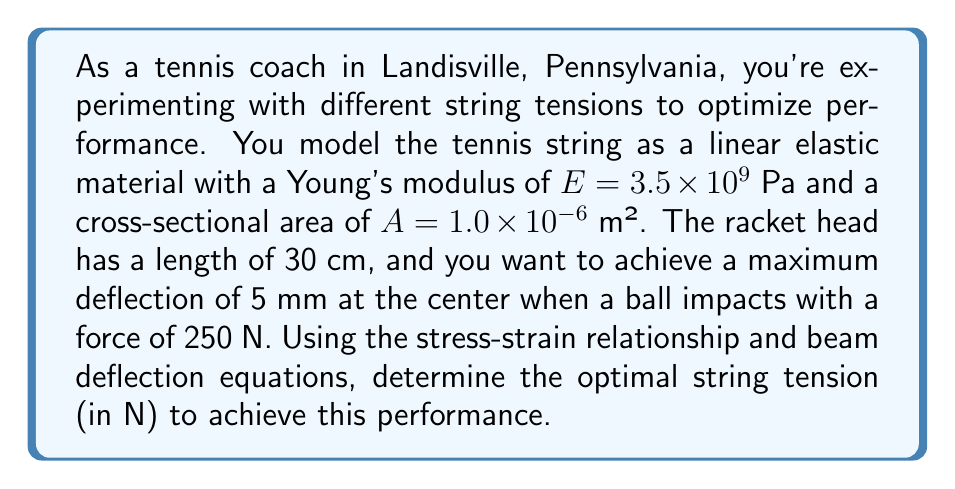Show me your answer to this math problem. To solve this problem, we'll use the following steps:

1) First, we need to use the beam deflection equation for a simply supported beam with a point load at the center:

   $$\delta_{max} = \frac{FL^3}{48EI}$$

   where $\delta_{max}$ is the maximum deflection, $F$ is the force, $L$ is the length, $E$ is Young's modulus, and $I$ is the moment of inertia.

2) We can rearrange this equation to solve for $I$:

   $$I = \frac{FL^3}{48E\delta_{max}}$$

3) Substituting the given values:

   $$I = \frac{250 \text{ N} \times (0.3 \text{ m})^3}{48 \times 3.5 \times 10^9 \text{ Pa} \times 0.005 \text{ m}} = 1.929 \times 10^{-9} \text{ m}^4$$

4) For a tensioned string, the moment of inertia is related to the tension $T$ by:

   $$I = \frac{TA^2}{4\pi^2}$$

5) We can rearrange this to solve for $T$:

   $$T = \frac{4\pi^2I}{A^2}$$

6) Substituting our calculated $I$ and the given $A$:

   $$T = \frac{4\pi^2 \times 1.929 \times 10^{-9} \text{ m}^4}{(1.0 \times 10^{-6} \text{ m}^2)^2} = 759.8 \text{ N}$$

Therefore, the optimal string tension is approximately 760 N.
Answer: 760 N 